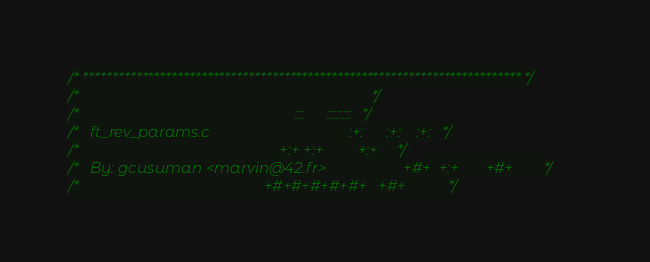<code> <loc_0><loc_0><loc_500><loc_500><_C_>/* ************************************************************************** */
/*                                                                            */
/*                                                        :::      ::::::::   */
/*   ft_rev_params.c                                    :+:      :+:    :+:   */
/*                                                    +:+ +:+         +:+     */
/*   By: gcusuman <marvin@42.fr>                    +#+  +:+       +#+        */
/*                                                +#+#+#+#+#+   +#+           */</code> 